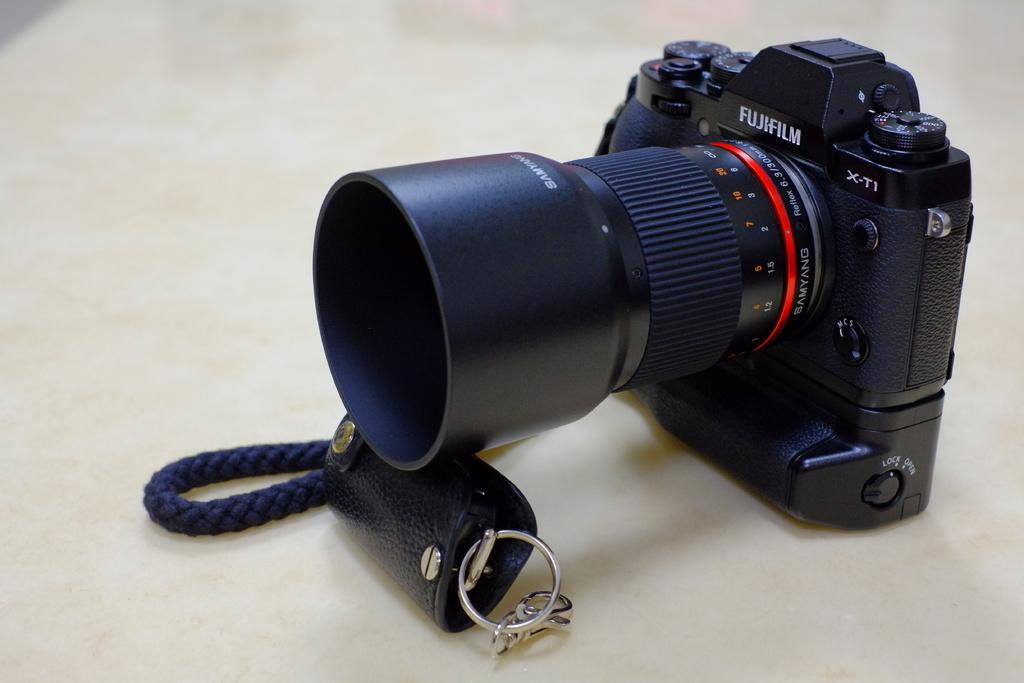Provide a one-sentence caption for the provided image. Black, white, and red fugifilm camera with reflex. 